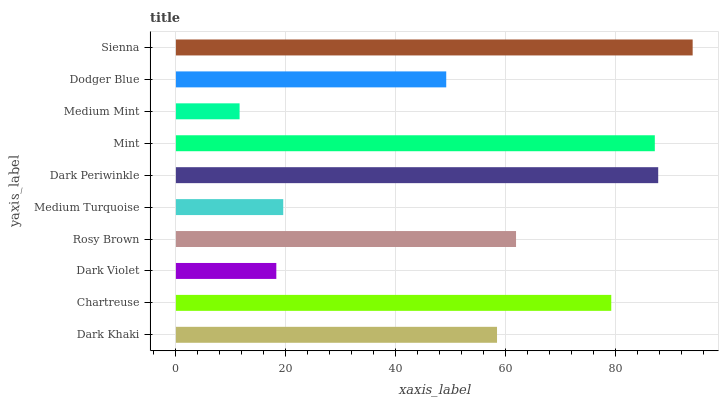Is Medium Mint the minimum?
Answer yes or no. Yes. Is Sienna the maximum?
Answer yes or no. Yes. Is Chartreuse the minimum?
Answer yes or no. No. Is Chartreuse the maximum?
Answer yes or no. No. Is Chartreuse greater than Dark Khaki?
Answer yes or no. Yes. Is Dark Khaki less than Chartreuse?
Answer yes or no. Yes. Is Dark Khaki greater than Chartreuse?
Answer yes or no. No. Is Chartreuse less than Dark Khaki?
Answer yes or no. No. Is Rosy Brown the high median?
Answer yes or no. Yes. Is Dark Khaki the low median?
Answer yes or no. Yes. Is Chartreuse the high median?
Answer yes or no. No. Is Dark Periwinkle the low median?
Answer yes or no. No. 